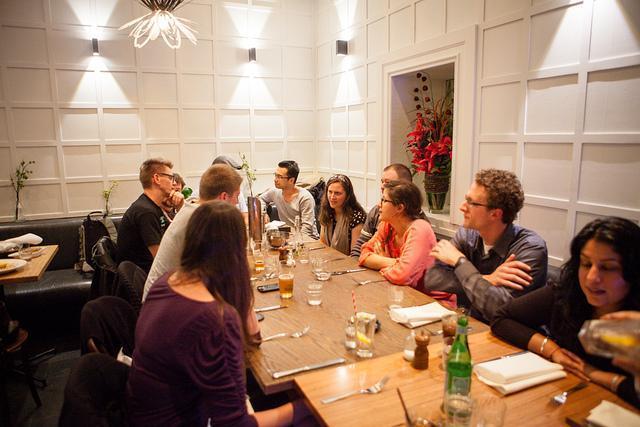How many people are there?
Give a very brief answer. 11. How many dining tables can you see?
Give a very brief answer. 2. How many chairs are in the picture?
Give a very brief answer. 2. How many people can you see?
Give a very brief answer. 8. How many red headlights does the train have?
Give a very brief answer. 0. 